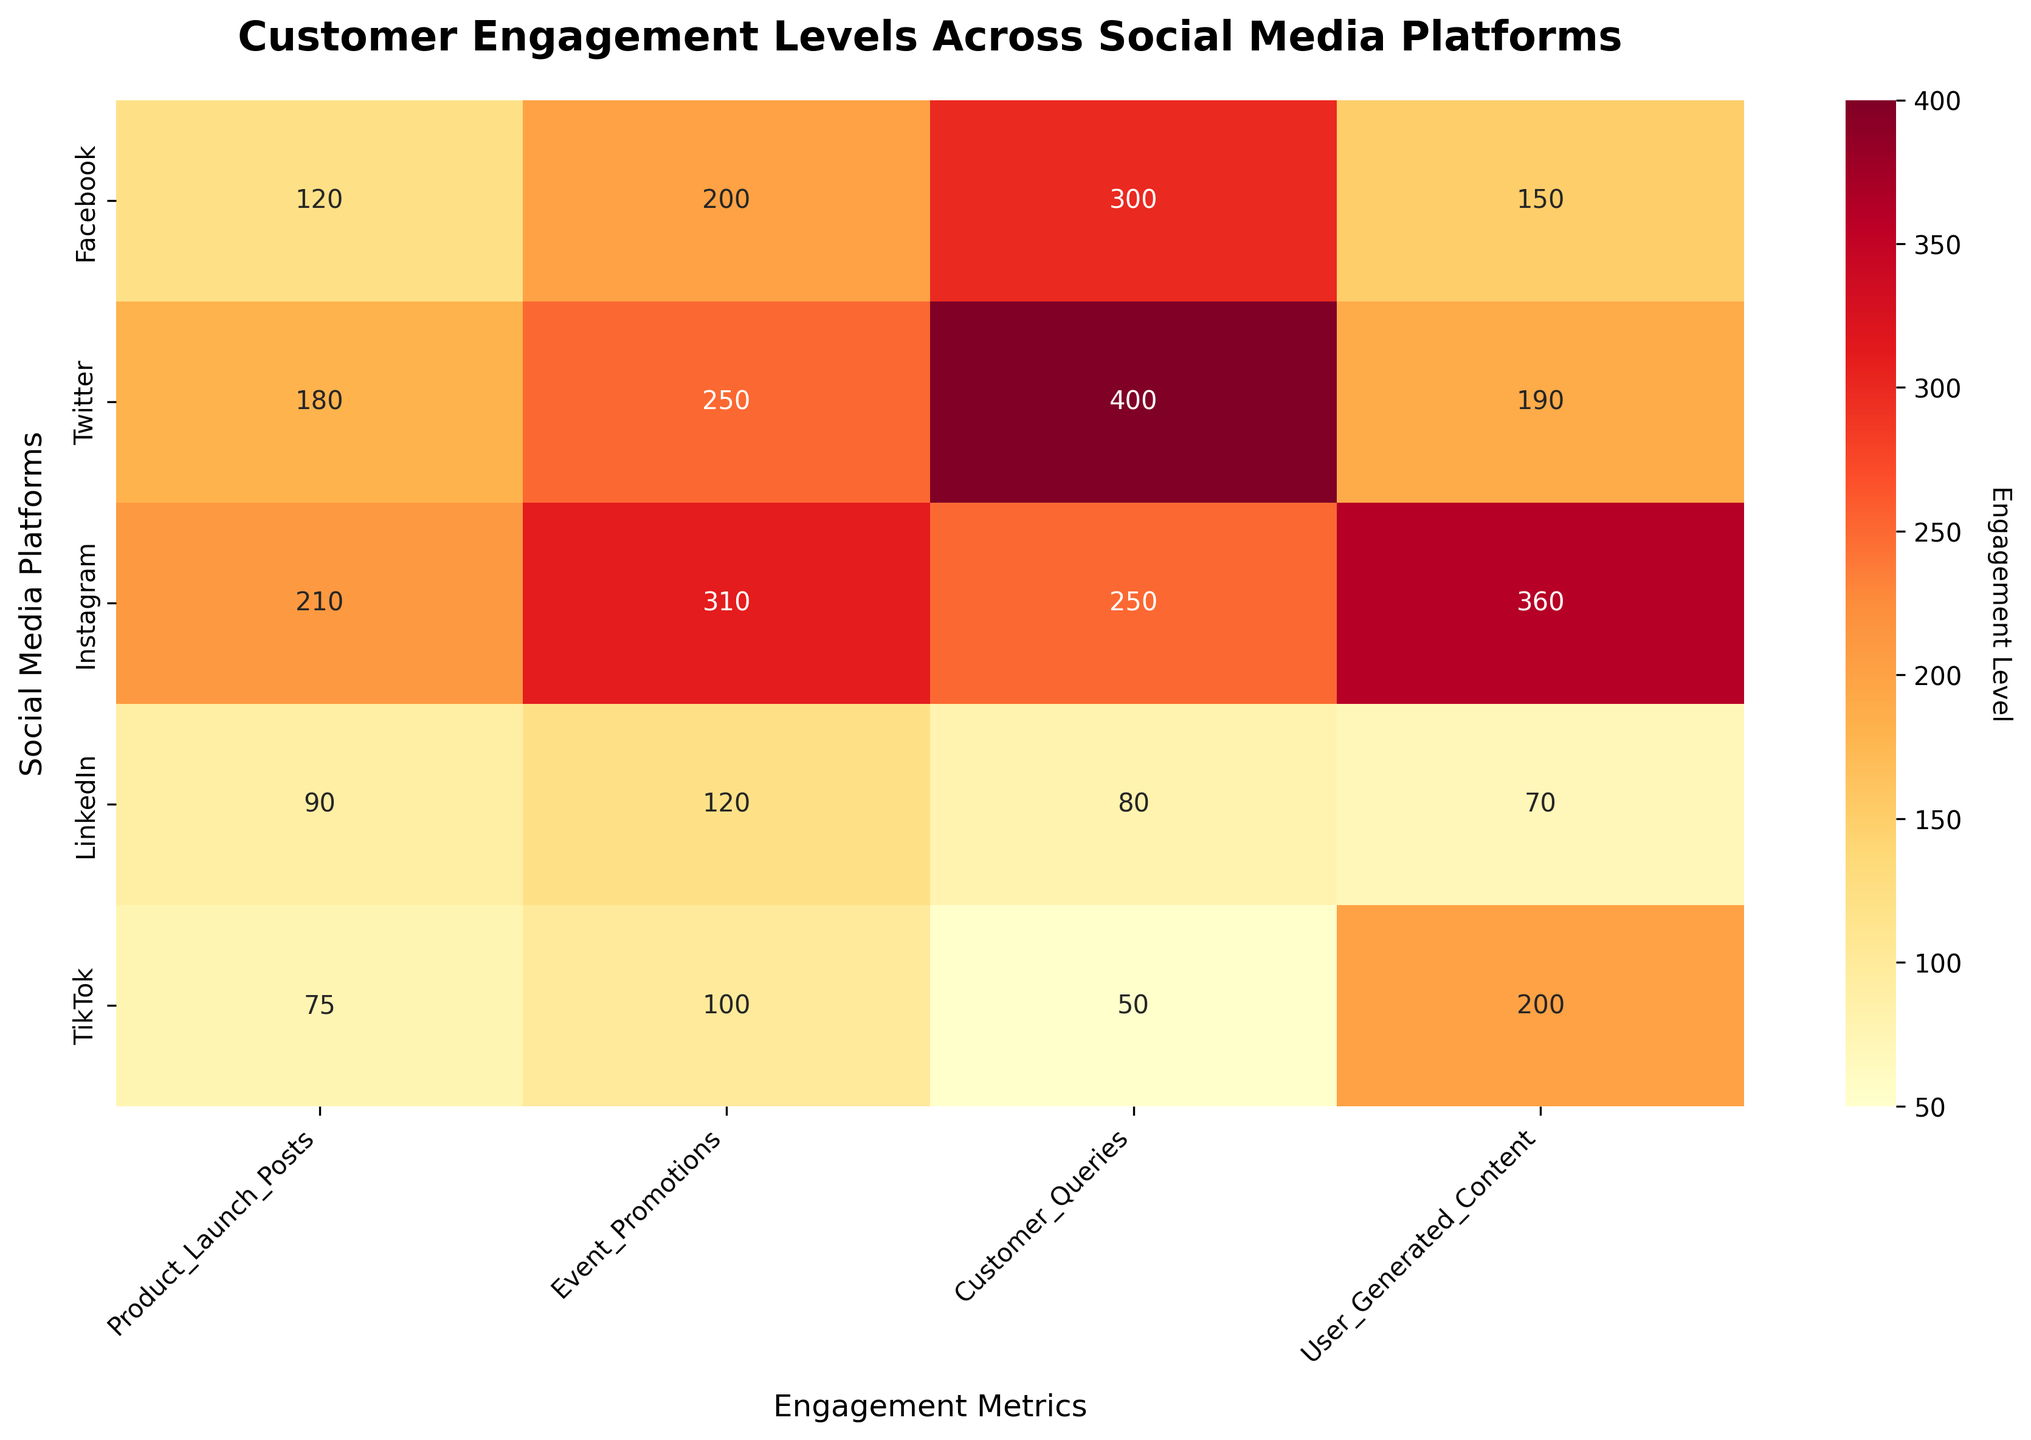What's the title of the heatmap? The title is displayed at the top of the heatmap and can be easily read directly from the figure.
Answer: Customer Engagement Levels Across Social Media Platforms Which social media platform has the highest engagement in Product Launch Posts? By looking at the heatmap cells under 'Product Launch Posts' and comparing their values, identify the highest value.
Answer: Instagram What's the sum of User Generated Content engagement on Facebook and TikTok? Find the values for Facebook and TikTok under 'User Generated Content' and add them up: 150 (Facebook) + 200 (TikTok).
Answer: 350 Which social media platform has the least engagement in Customer Queries? Look at the cells under 'Customer Queries' and identify the smallest value, then note the platform name.
Answer: TikTok How does Facebook's engagement in Event Promotions compare to Twitter's? Compare the values in the 'Event Promotions' row for Facebook (200) and Twitter (250). Twitter's engagement is higher than Facebook's.
Answer: Twitter's engagement is higher Which platform has more overall engagement: Facebook in Event Promotions or Instagram in Product Launch Posts? Compare the values for Facebook in 'Event Promotions' (200) and Instagram in 'Product Launch Posts' (210).
Answer: Instagram What's the total engagement for product-related activities (sum of Product Launch Posts and Event Promotions) on LinkedIn? Add the values of 'Product Launch Posts' (90) and 'Event Promotions' (120) for LinkedIn: 90 + 120.
Answer: 210 Which engagement metric shows the greatest difference between Instagram and LinkedIn? Calculate the absolute differences across each metric for Instagram and LinkedIn:
- Product Launch Posts: 210 - 90 = 120
- Event Promotions: 310 - 120 = 190
- Customer Queries: 250 - 80 = 170
- User Generated Content: 360 - 70 = 290
The greatest difference is in User Generated Content (290).
Answer: User Generated Content Which platform has the overall highest levels of engagement in User Generated Content? Look for the highest value under the 'User Generated Content' column and note the platform.
Answer: Instagram Calculate the average engagement in Customer Queries across all platforms. Sum the values in the 'Customer Queries' column and divide by the number of platforms: (300 + 400 + 250 + 80 + 50) / 5 = 1080 / 5.
Answer: 216 